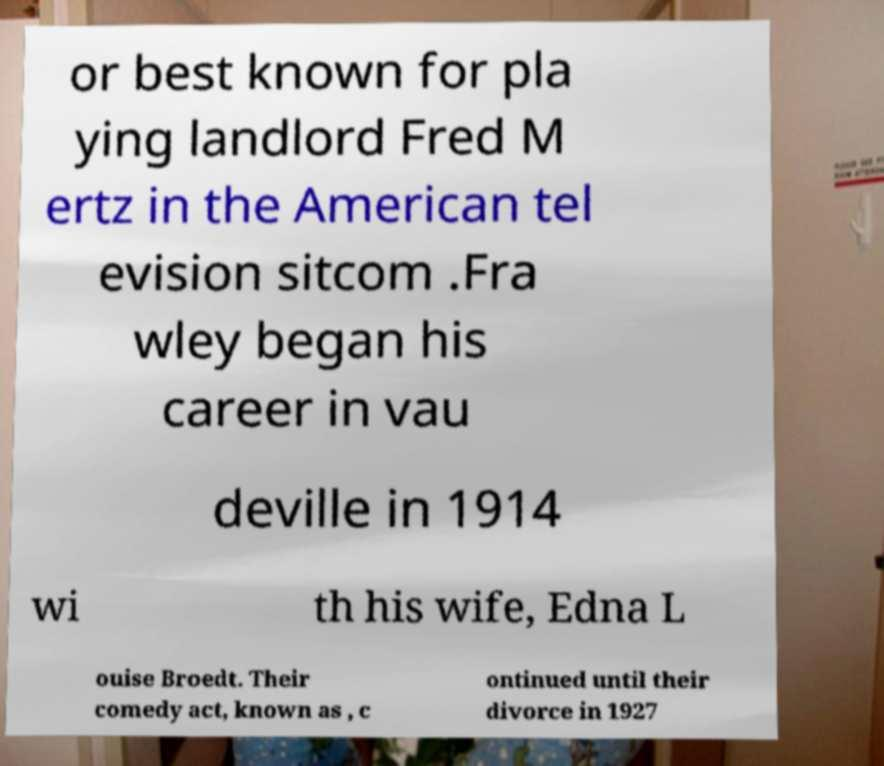Could you assist in decoding the text presented in this image and type it out clearly? or best known for pla ying landlord Fred M ertz in the American tel evision sitcom .Fra wley began his career in vau deville in 1914 wi th his wife, Edna L ouise Broedt. Their comedy act, known as , c ontinued until their divorce in 1927 